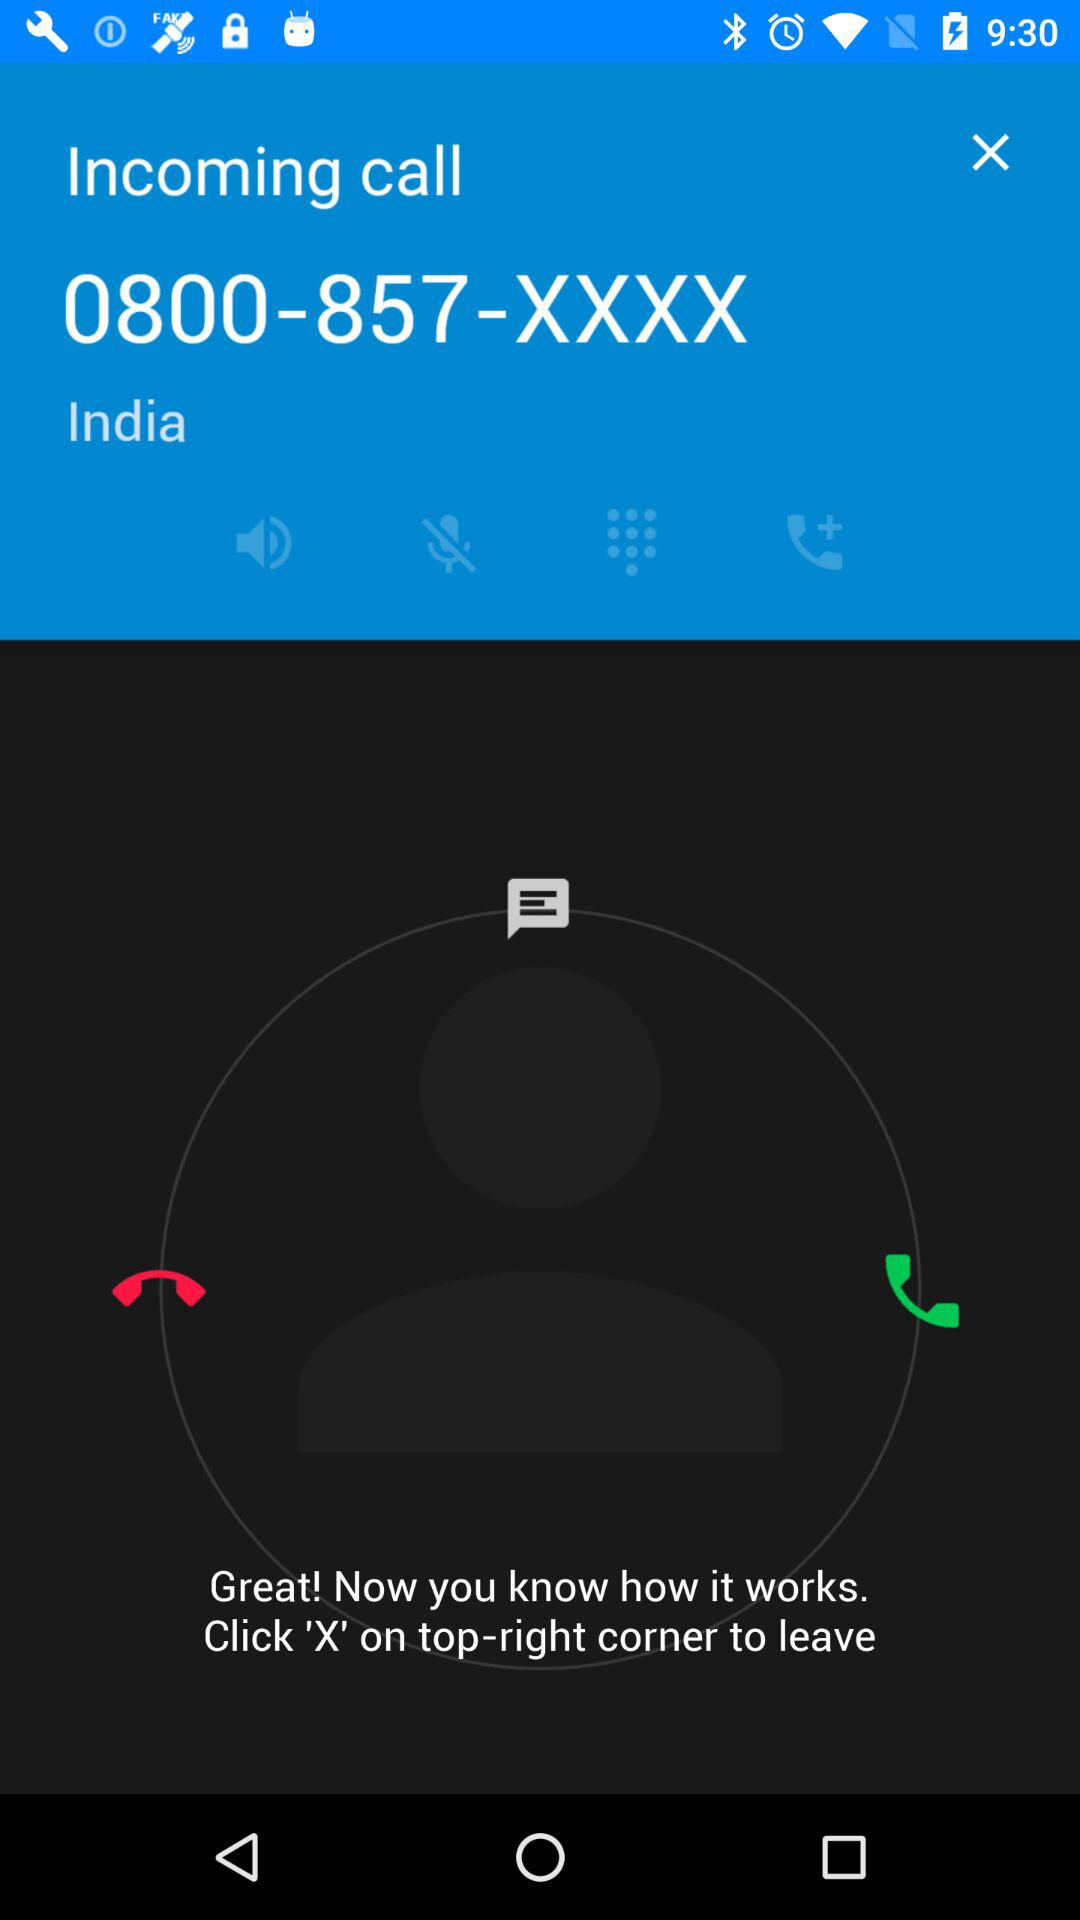Which country is the shown number from? The shown number is from India. 